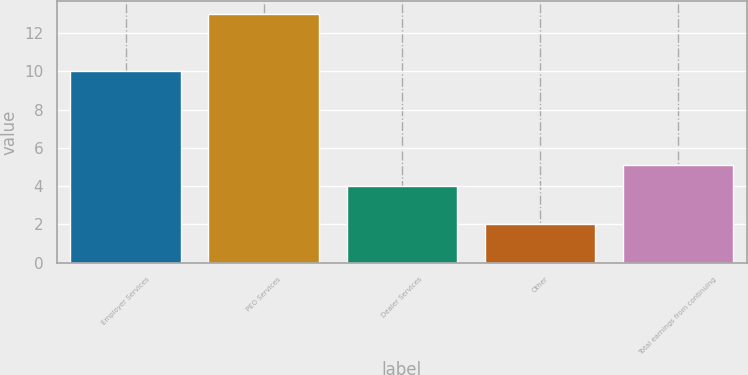Convert chart. <chart><loc_0><loc_0><loc_500><loc_500><bar_chart><fcel>Employer Services<fcel>PEO Services<fcel>Dealer Services<fcel>Other<fcel>Total earnings from continuing<nl><fcel>10<fcel>13<fcel>4<fcel>2<fcel>5.1<nl></chart> 